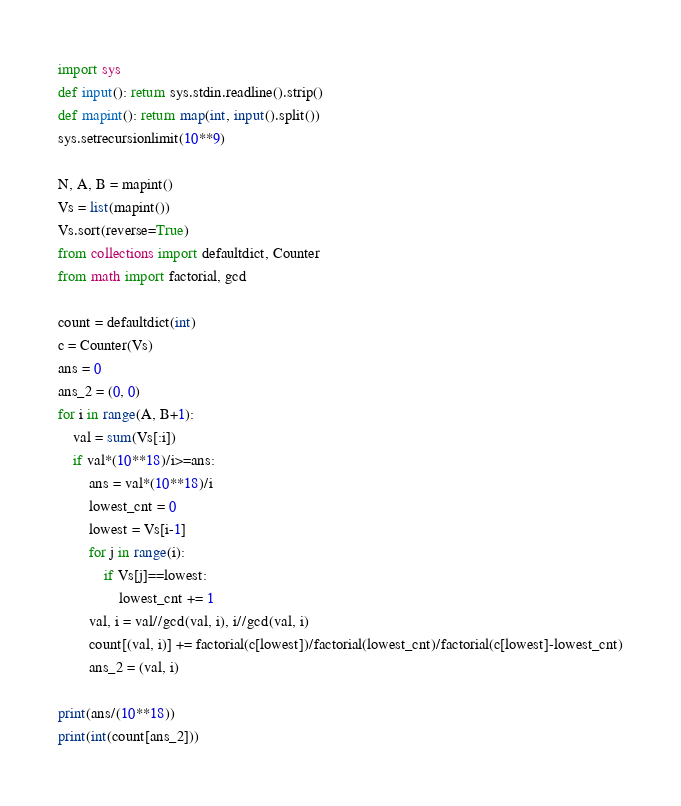<code> <loc_0><loc_0><loc_500><loc_500><_Python_>import sys
def input(): return sys.stdin.readline().strip()
def mapint(): return map(int, input().split())
sys.setrecursionlimit(10**9)

N, A, B = mapint()
Vs = list(mapint())
Vs.sort(reverse=True)
from collections import defaultdict, Counter
from math import factorial, gcd

count = defaultdict(int)
c = Counter(Vs)
ans = 0
ans_2 = (0, 0)
for i in range(A, B+1):
    val = sum(Vs[:i])
    if val*(10**18)/i>=ans:
        ans = val*(10**18)/i
        lowest_cnt = 0
        lowest = Vs[i-1]
        for j in range(i):
            if Vs[j]==lowest:
                lowest_cnt += 1
        val, i = val//gcd(val, i), i//gcd(val, i)
        count[(val, i)] += factorial(c[lowest])/factorial(lowest_cnt)/factorial(c[lowest]-lowest_cnt)
        ans_2 = (val, i)

print(ans/(10**18))
print(int(count[ans_2]))</code> 